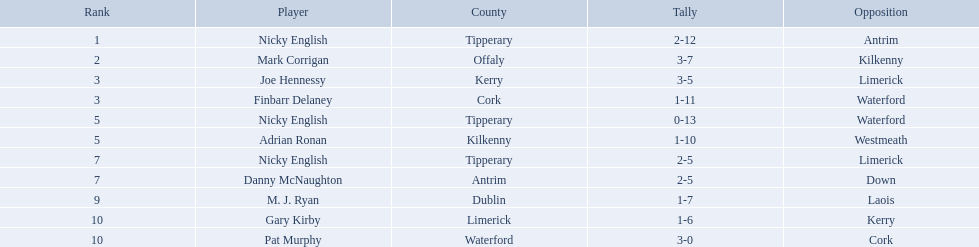What numbers are in the total column? 18, 16, 14, 14, 13, 13, 11, 11, 10, 9, 9. What row has the number 10 in the total column? 9, M. J. Ryan, Dublin, 1-7, 10, Laois. What name is in the player column for this row? M. J. Ryan. Who are all the players? Nicky English, Mark Corrigan, Joe Hennessy, Finbarr Delaney, Nicky English, Adrian Ronan, Nicky English, Danny McNaughton, M. J. Ryan, Gary Kirby, Pat Murphy. How many points did they receive? 18, 16, 14, 14, 13, 13, 11, 11, 10, 9, 9. And which player received 10 points? M. J. Ryan. 